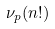<formula> <loc_0><loc_0><loc_500><loc_500>\nu _ { p } ( n ! )</formula> 